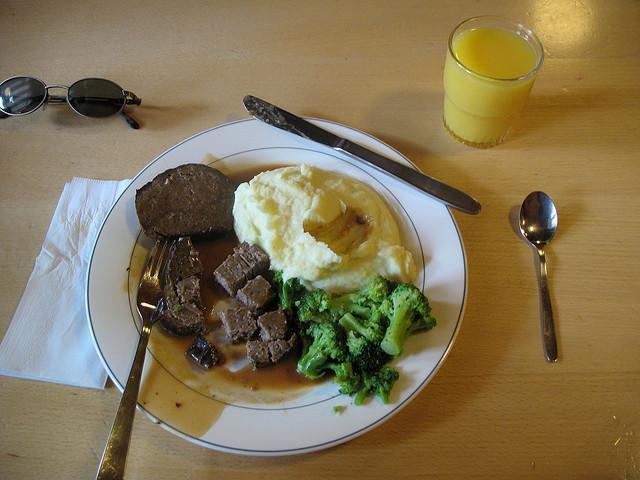Which food on the plate is highest carbohydrates?
Select the accurate answer and provide explanation: 'Answer: answer
Rationale: rationale.'
Options: Beef, gravy, potatoes, broccoli. Answer: potatoes.
Rationale: The white mass present on this plate is mashed potatoes. this vegetable is known for it's high carbohydrate content. 